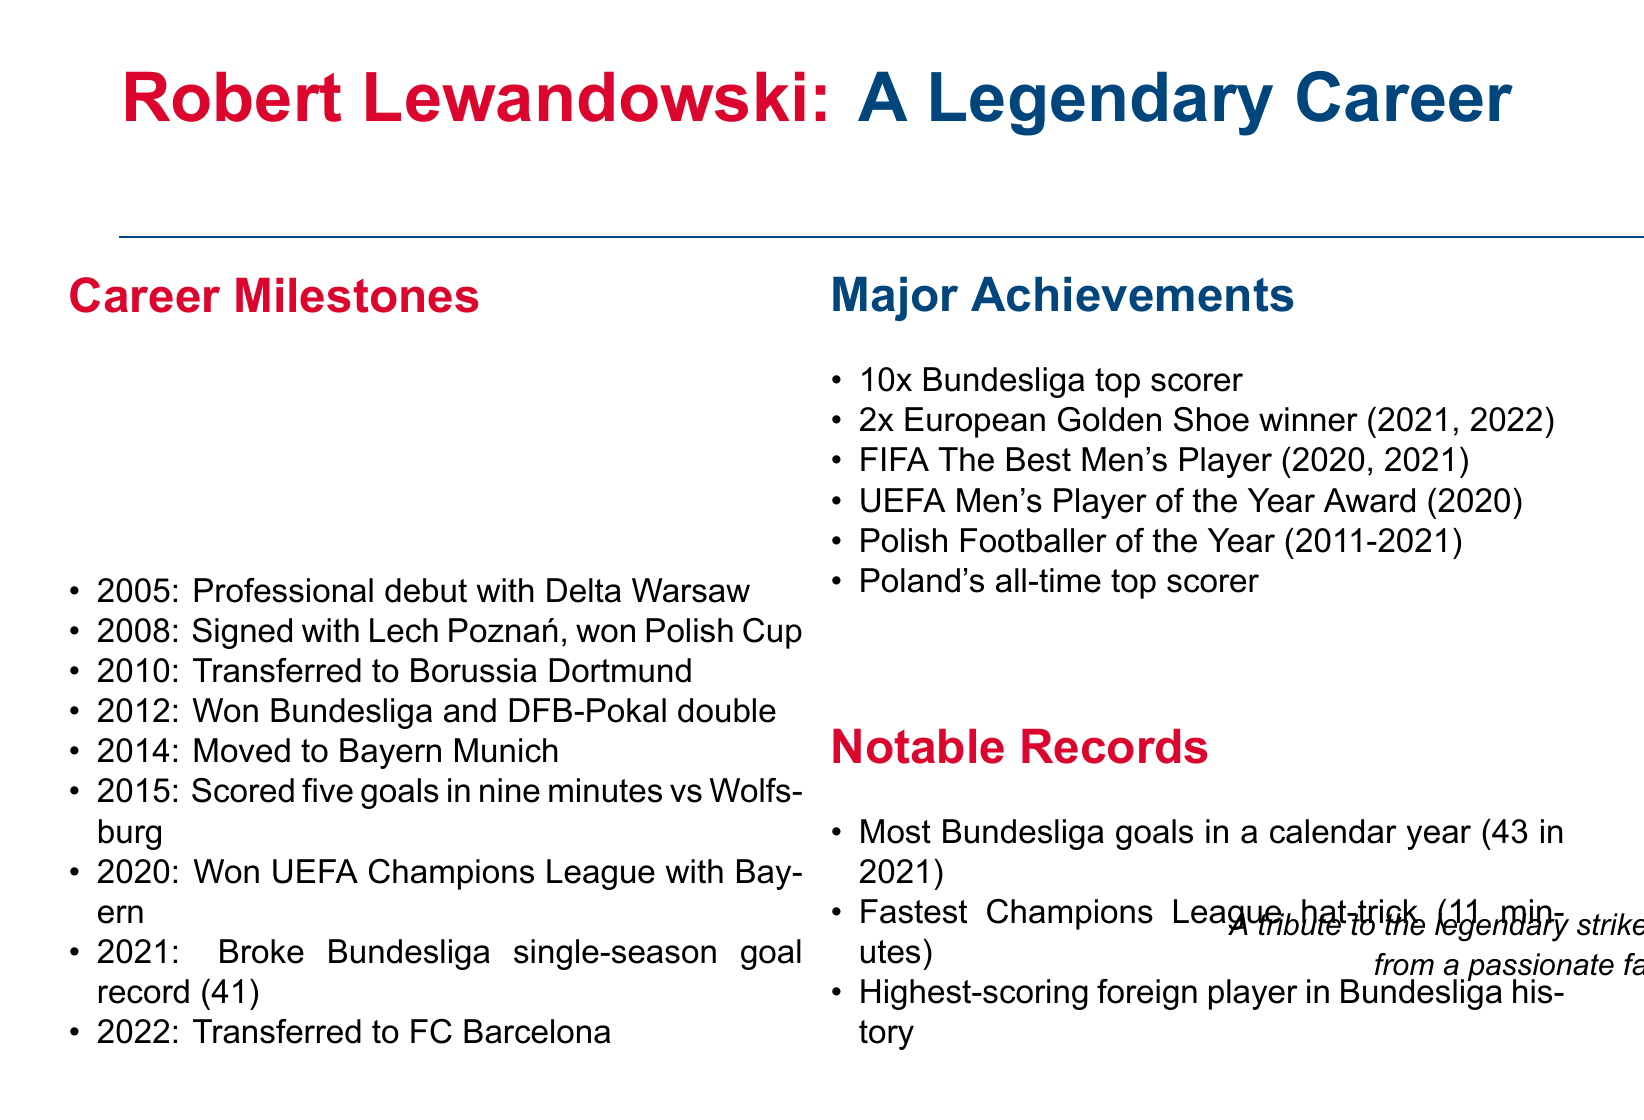What year did Lewandowski make his professional debut? The document states that Lewandowski made his professional debut in 2005.
Answer: 2005 Which club did Lewandowski join in 2008? According to the document, Lewandowski signed with Lech Poznań in 2008.
Answer: Lech Poznań How many goals did Lewandowski score to break the Bundesliga single-season goal record? The document mentions that Lewandowski broke the record by scoring 41 goals.
Answer: 41 goals What significant event occurred for Lewandowski in 2020? The timeline indicates that he won the UEFA Champions League with Bayern Munich in 2020.
Answer: Won UEFA Champions League How many times did Lewandowski win the European Golden Shoe? The achievements section states that he won the European Golden Shoe twice.
Answer: 2 times What is the fastest time for a Champions League hat-trick recorded by Lewandowski? The document notes that he achieved the fastest hat-trick in just 11 minutes.
Answer: 11 minutes What achievement indicates Lewandowski's status in Poland's football history? The document highlights that he is recognized as Poland's all-time top scorer.
Answer: Poland's all-time top scorer In what year did Lewandowski transfer to FC Barcelona? According to the timeline, Lewandowski transferred to FC Barcelona in 2022.
Answer: 2022 How many times was Lewandowski named Polish Footballer of the Year? The achievements section of the document states that he was named Polish Footballer of the Year for 11 years.
Answer: 11 years 